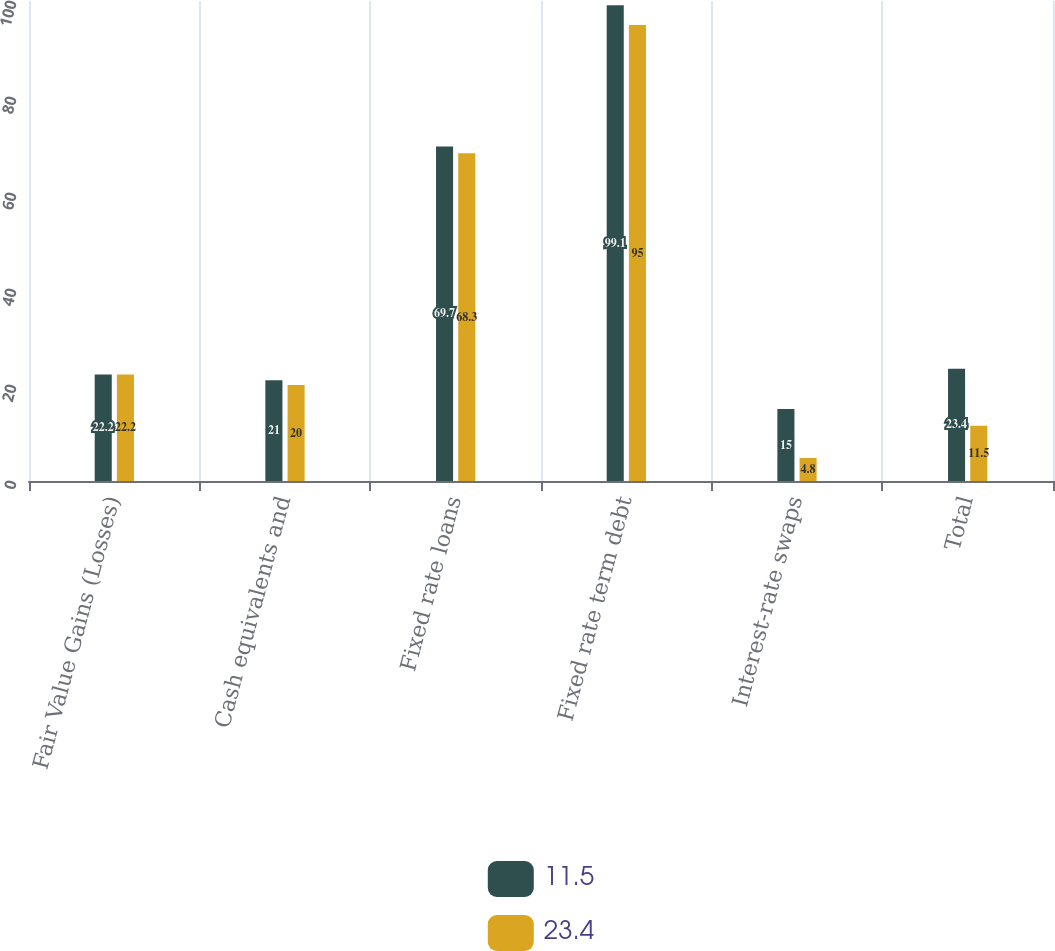Convert chart. <chart><loc_0><loc_0><loc_500><loc_500><stacked_bar_chart><ecel><fcel>Fair Value Gains (Losses)<fcel>Cash equivalents and<fcel>Fixed rate loans<fcel>Fixed rate term debt<fcel>Interest-rate swaps<fcel>Total<nl><fcel>11.5<fcel>22.2<fcel>21<fcel>69.7<fcel>99.1<fcel>15<fcel>23.4<nl><fcel>23.4<fcel>22.2<fcel>20<fcel>68.3<fcel>95<fcel>4.8<fcel>11.5<nl></chart> 